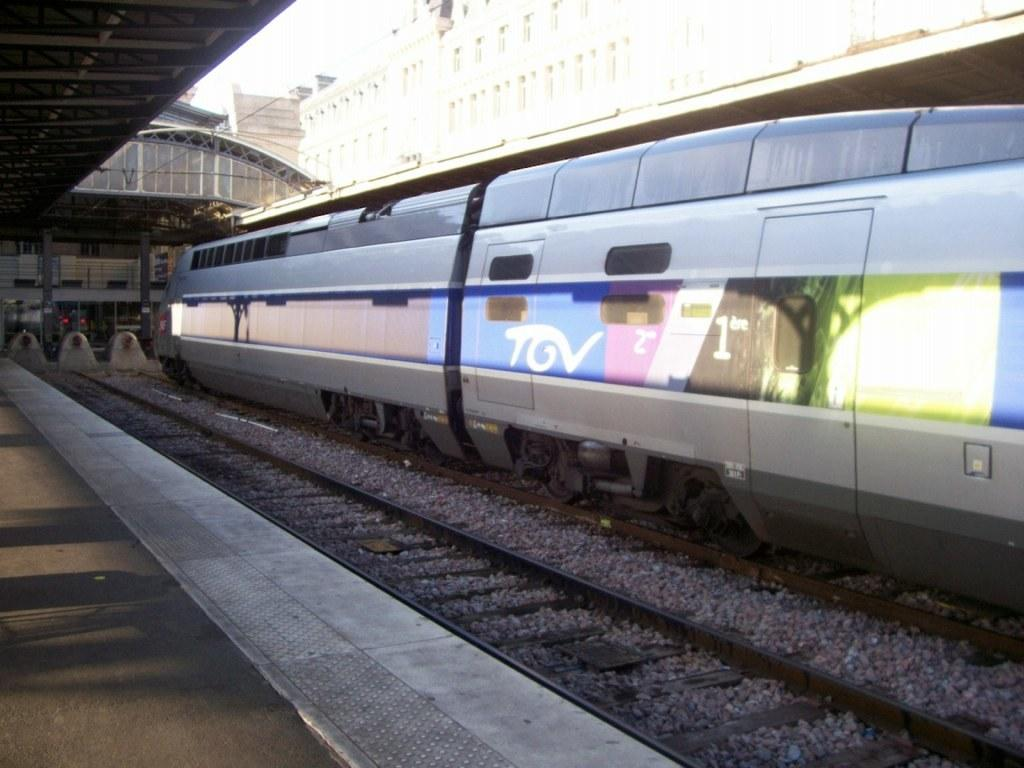<image>
Present a compact description of the photo's key features. An advertisement on the side of a subway train for TGV. 